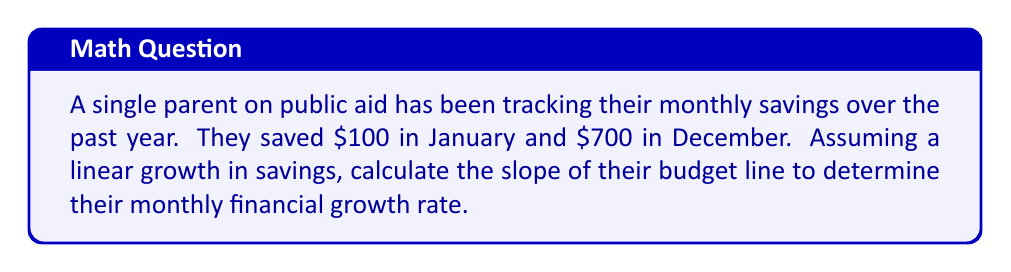Provide a solution to this math problem. To solve this problem, we'll use the slope formula for a line:

$$ m = \frac{y_2 - y_1}{x_2 - x_1} $$

Where:
- $m$ is the slope (monthly growth rate)
- $(x_1, y_1)$ is the initial point (January savings)
- $(x_2, y_2)$ is the final point (December savings)

Let's define our points:
- January (month 1): $(1, 100)$
- December (month 12): $(12, 700)$

Plugging these into the slope formula:

$$ m = \frac{700 - 100}{12 - 1} = \frac{600}{11} $$

Simplifying:

$$ m = \frac{600}{11} \approx 54.55 $$

This slope represents the average monthly increase in savings. To convert it to a percentage growth rate, we need to divide by the initial savings and multiply by 100:

$$ \text{Growth Rate} = \frac{54.55}{100} \times 100\% = 54.55\% $$
Answer: The slope of the budget line is approximately $54.55, representing an average monthly savings increase of $54.55 or a 54.55% monthly growth rate. 